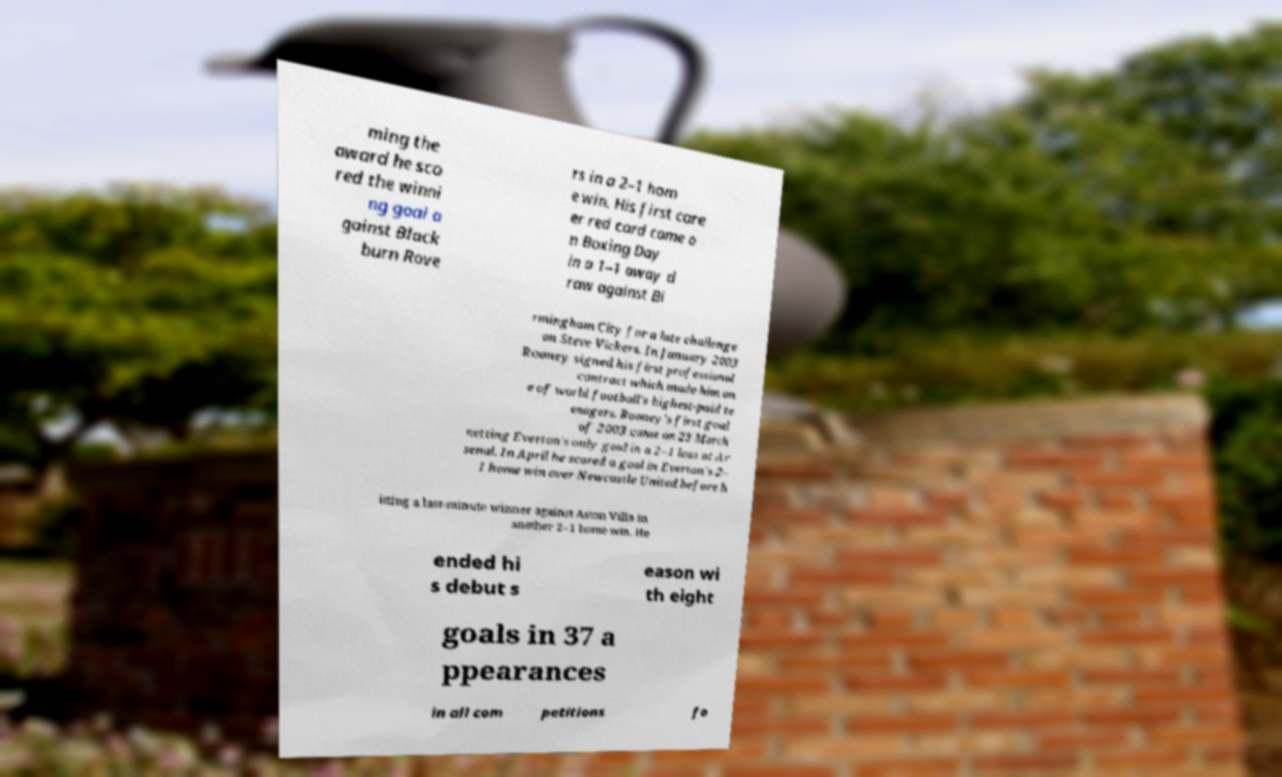Could you assist in decoding the text presented in this image and type it out clearly? ming the award he sco red the winni ng goal a gainst Black burn Rove rs in a 2–1 hom e win. His first care er red card came o n Boxing Day in a 1–1 away d raw against Bi rmingham City for a late challenge on Steve Vickers. In January 2003 Rooney signed his first professional contract which made him on e of world football's highest-paid te enagers. Rooney's first goal of 2003 came on 23 March netting Everton's only goal in a 2–1 loss at Ar senal. In April he scored a goal in Everton's 2– 1 home win over Newcastle United before h itting a last-minute winner against Aston Villa in another 2–1 home win. He ended hi s debut s eason wi th eight goals in 37 a ppearances in all com petitions fo 